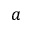<formula> <loc_0><loc_0><loc_500><loc_500>a</formula> 